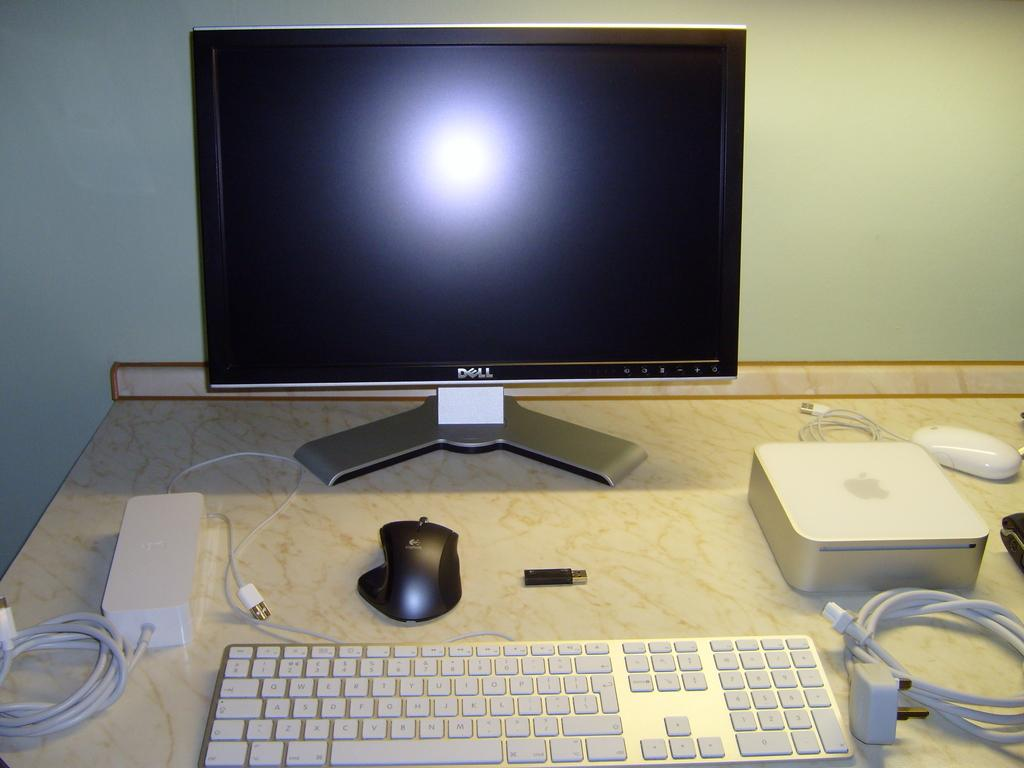<image>
Relay a brief, clear account of the picture shown. the word dell that is on a screen 